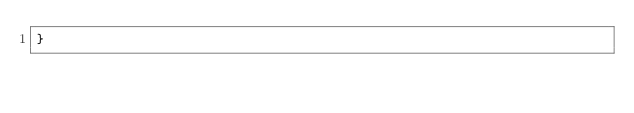Convert code to text. <code><loc_0><loc_0><loc_500><loc_500><_CSS_>}</code> 